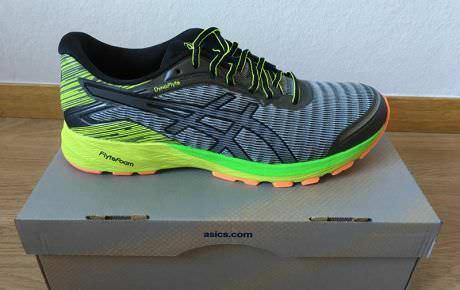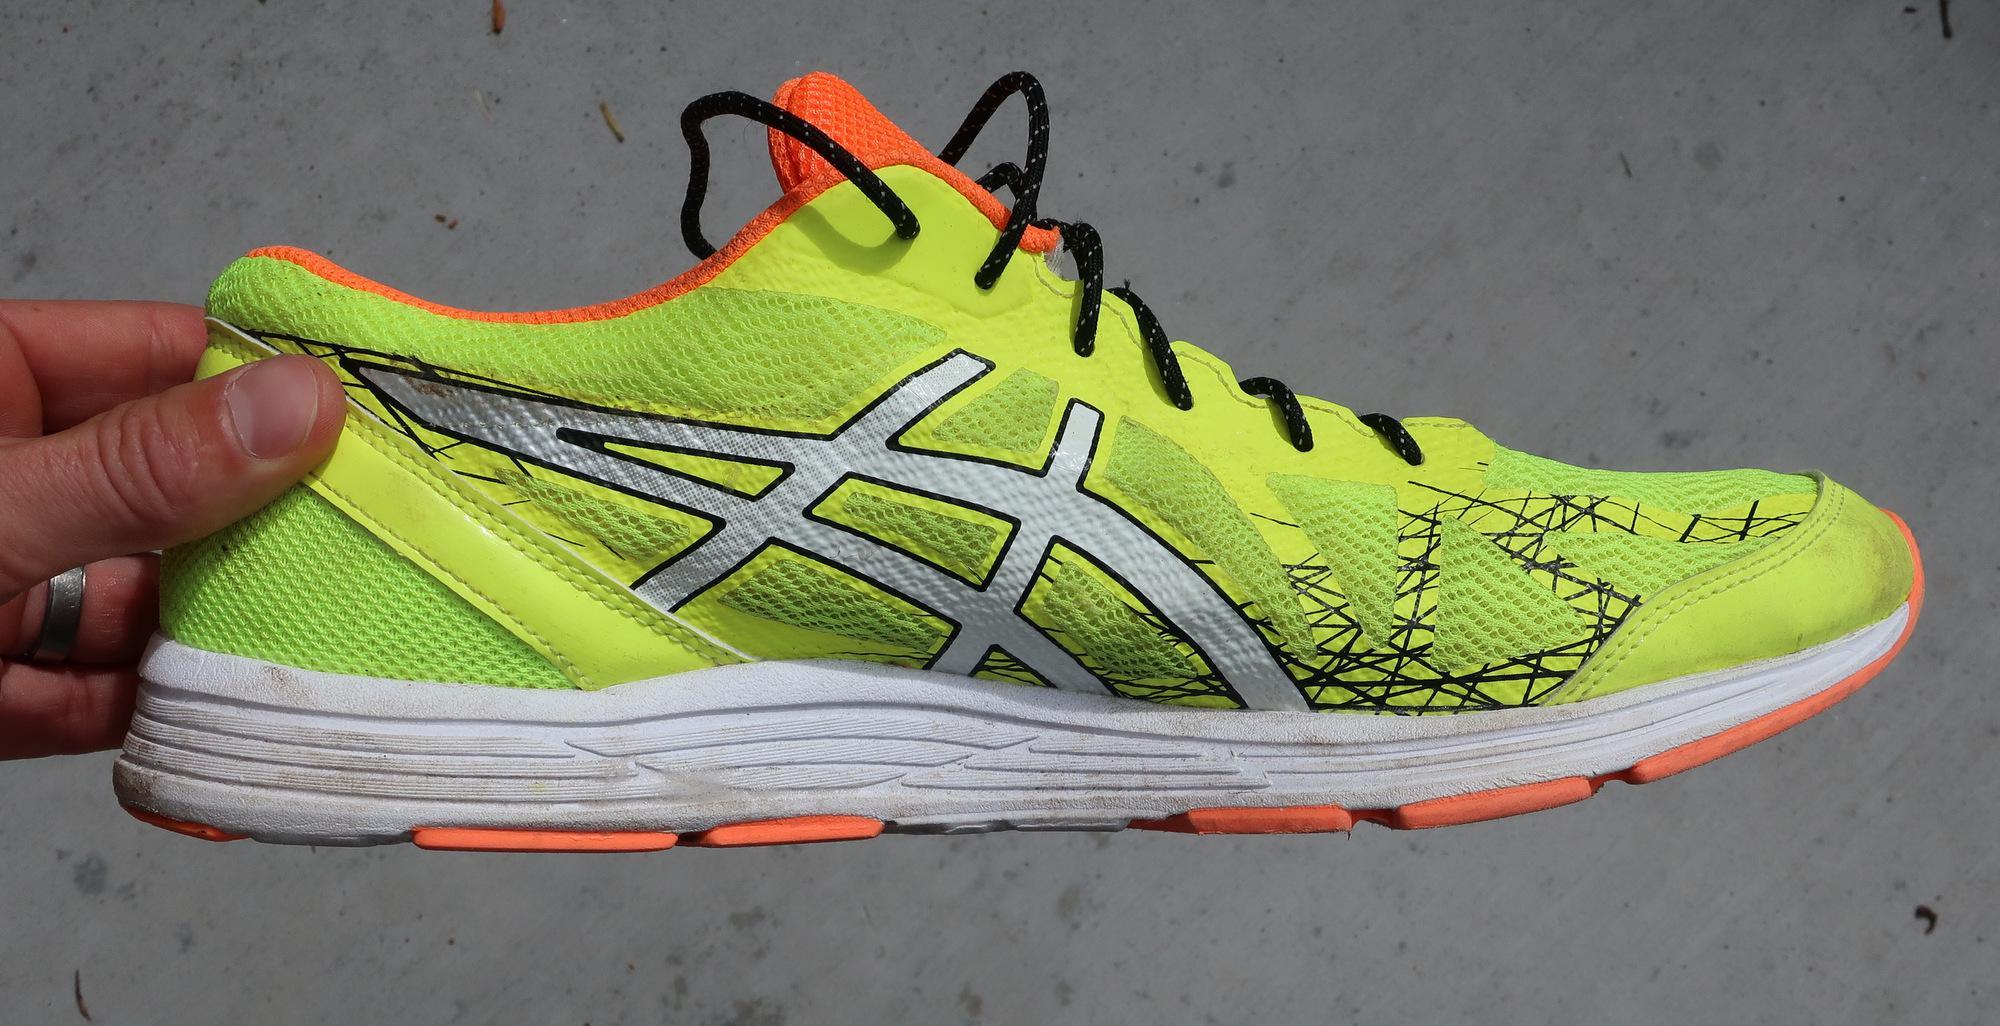The first image is the image on the left, the second image is the image on the right. Assess this claim about the two images: "A shoe is sitting on top of another object.". Correct or not? Answer yes or no. Yes. The first image is the image on the left, the second image is the image on the right. For the images displayed, is the sentence "There are exactly two sneakers." factually correct? Answer yes or no. Yes. 